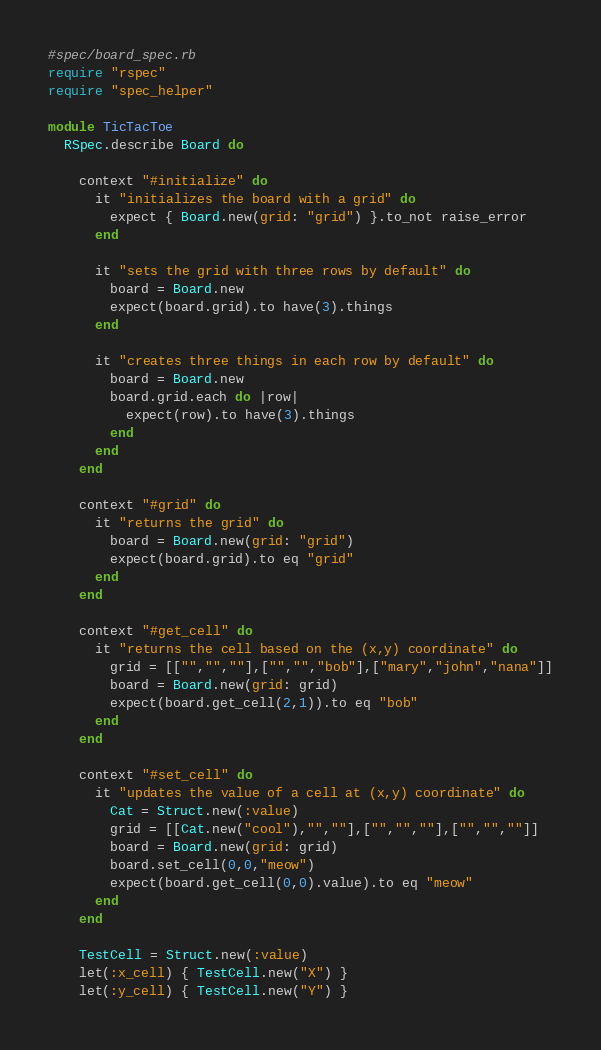Convert code to text. <code><loc_0><loc_0><loc_500><loc_500><_Ruby_>#spec/board_spec.rb
require "rspec"
require "spec_helper"

module TicTacToe
  RSpec.describe Board do

    context "#initialize" do
      it "initializes the board with a grid" do
        expect { Board.new(grid: "grid") }.to_not raise_error
      end

      it "sets the grid with three rows by default" do
        board = Board.new
        expect(board.grid).to have(3).things
      end

      it "creates three things in each row by default" do
        board = Board.new
        board.grid.each do |row|
          expect(row).to have(3).things
        end
      end
    end

    context "#grid" do
      it "returns the grid" do
        board = Board.new(grid: "grid")
        expect(board.grid).to eq "grid"
      end
    end

    context "#get_cell" do
      it "returns the cell based on the (x,y) coordinate" do
        grid = [["","",""],["","","bob"],["mary","john","nana"]]
        board = Board.new(grid: grid)
        expect(board.get_cell(2,1)).to eq "bob"
      end
    end

    context "#set_cell" do
      it "updates the value of a cell at (x,y) coordinate" do
        Cat = Struct.new(:value)
        grid = [[Cat.new("cool"),"",""],["","",""],["","",""]]
        board = Board.new(grid: grid)
        board.set_cell(0,0,"meow")
        expect(board.get_cell(0,0).value).to eq "meow"
      end
    end

    TestCell = Struct.new(:value)
    let(:x_cell) { TestCell.new("X") }
    let(:y_cell) { TestCell.new("Y") }</code> 